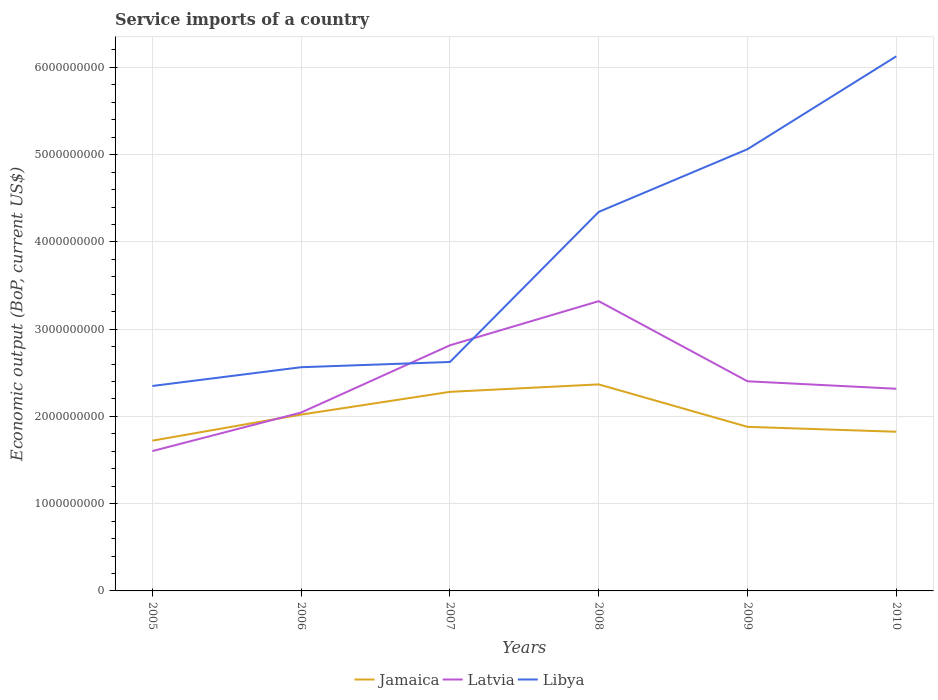Is the number of lines equal to the number of legend labels?
Your answer should be very brief. Yes. Across all years, what is the maximum service imports in Latvia?
Keep it short and to the point. 1.60e+09. What is the total service imports in Latvia in the graph?
Provide a short and direct response. -2.73e+08. What is the difference between the highest and the second highest service imports in Jamaica?
Keep it short and to the point. 6.45e+08. What is the difference between the highest and the lowest service imports in Latvia?
Provide a short and direct response. 2. Is the service imports in Latvia strictly greater than the service imports in Jamaica over the years?
Keep it short and to the point. No. How many lines are there?
Keep it short and to the point. 3. What is the difference between two consecutive major ticks on the Y-axis?
Provide a short and direct response. 1.00e+09. Does the graph contain any zero values?
Ensure brevity in your answer.  No. Does the graph contain grids?
Ensure brevity in your answer.  Yes. What is the title of the graph?
Offer a very short reply. Service imports of a country. Does "Kiribati" appear as one of the legend labels in the graph?
Offer a terse response. No. What is the label or title of the X-axis?
Offer a very short reply. Years. What is the label or title of the Y-axis?
Provide a short and direct response. Economic output (BoP, current US$). What is the Economic output (BoP, current US$) in Jamaica in 2005?
Your response must be concise. 1.72e+09. What is the Economic output (BoP, current US$) in Latvia in 2005?
Offer a terse response. 1.60e+09. What is the Economic output (BoP, current US$) of Libya in 2005?
Make the answer very short. 2.35e+09. What is the Economic output (BoP, current US$) in Jamaica in 2006?
Ensure brevity in your answer.  2.02e+09. What is the Economic output (BoP, current US$) in Latvia in 2006?
Your answer should be very brief. 2.04e+09. What is the Economic output (BoP, current US$) of Libya in 2006?
Offer a very short reply. 2.56e+09. What is the Economic output (BoP, current US$) in Jamaica in 2007?
Keep it short and to the point. 2.28e+09. What is the Economic output (BoP, current US$) in Latvia in 2007?
Your answer should be very brief. 2.82e+09. What is the Economic output (BoP, current US$) of Libya in 2007?
Provide a short and direct response. 2.62e+09. What is the Economic output (BoP, current US$) of Jamaica in 2008?
Make the answer very short. 2.37e+09. What is the Economic output (BoP, current US$) of Latvia in 2008?
Give a very brief answer. 3.32e+09. What is the Economic output (BoP, current US$) in Libya in 2008?
Offer a terse response. 4.34e+09. What is the Economic output (BoP, current US$) in Jamaica in 2009?
Your answer should be compact. 1.88e+09. What is the Economic output (BoP, current US$) of Latvia in 2009?
Keep it short and to the point. 2.40e+09. What is the Economic output (BoP, current US$) in Libya in 2009?
Provide a succinct answer. 5.06e+09. What is the Economic output (BoP, current US$) of Jamaica in 2010?
Your answer should be very brief. 1.82e+09. What is the Economic output (BoP, current US$) in Latvia in 2010?
Offer a terse response. 2.32e+09. What is the Economic output (BoP, current US$) in Libya in 2010?
Your response must be concise. 6.13e+09. Across all years, what is the maximum Economic output (BoP, current US$) of Jamaica?
Ensure brevity in your answer.  2.37e+09. Across all years, what is the maximum Economic output (BoP, current US$) of Latvia?
Your answer should be compact. 3.32e+09. Across all years, what is the maximum Economic output (BoP, current US$) in Libya?
Offer a terse response. 6.13e+09. Across all years, what is the minimum Economic output (BoP, current US$) of Jamaica?
Your answer should be very brief. 1.72e+09. Across all years, what is the minimum Economic output (BoP, current US$) of Latvia?
Offer a very short reply. 1.60e+09. Across all years, what is the minimum Economic output (BoP, current US$) of Libya?
Your answer should be very brief. 2.35e+09. What is the total Economic output (BoP, current US$) in Jamaica in the graph?
Keep it short and to the point. 1.21e+1. What is the total Economic output (BoP, current US$) in Latvia in the graph?
Provide a short and direct response. 1.45e+1. What is the total Economic output (BoP, current US$) in Libya in the graph?
Ensure brevity in your answer.  2.31e+1. What is the difference between the Economic output (BoP, current US$) of Jamaica in 2005 and that in 2006?
Give a very brief answer. -2.99e+08. What is the difference between the Economic output (BoP, current US$) of Latvia in 2005 and that in 2006?
Make the answer very short. -4.42e+08. What is the difference between the Economic output (BoP, current US$) in Libya in 2005 and that in 2006?
Make the answer very short. -2.15e+08. What is the difference between the Economic output (BoP, current US$) of Jamaica in 2005 and that in 2007?
Your answer should be very brief. -5.60e+08. What is the difference between the Economic output (BoP, current US$) of Latvia in 2005 and that in 2007?
Offer a terse response. -1.21e+09. What is the difference between the Economic output (BoP, current US$) of Libya in 2005 and that in 2007?
Provide a short and direct response. -2.75e+08. What is the difference between the Economic output (BoP, current US$) of Jamaica in 2005 and that in 2008?
Offer a very short reply. -6.45e+08. What is the difference between the Economic output (BoP, current US$) of Latvia in 2005 and that in 2008?
Your response must be concise. -1.72e+09. What is the difference between the Economic output (BoP, current US$) of Libya in 2005 and that in 2008?
Offer a very short reply. -2.00e+09. What is the difference between the Economic output (BoP, current US$) in Jamaica in 2005 and that in 2009?
Your answer should be compact. -1.59e+08. What is the difference between the Economic output (BoP, current US$) of Latvia in 2005 and that in 2009?
Your answer should be compact. -8.00e+08. What is the difference between the Economic output (BoP, current US$) of Libya in 2005 and that in 2009?
Ensure brevity in your answer.  -2.71e+09. What is the difference between the Economic output (BoP, current US$) in Jamaica in 2005 and that in 2010?
Provide a succinct answer. -1.02e+08. What is the difference between the Economic output (BoP, current US$) of Latvia in 2005 and that in 2010?
Your answer should be compact. -7.14e+08. What is the difference between the Economic output (BoP, current US$) of Libya in 2005 and that in 2010?
Offer a very short reply. -3.78e+09. What is the difference between the Economic output (BoP, current US$) in Jamaica in 2006 and that in 2007?
Give a very brief answer. -2.61e+08. What is the difference between the Economic output (BoP, current US$) in Latvia in 2006 and that in 2007?
Keep it short and to the point. -7.71e+08. What is the difference between the Economic output (BoP, current US$) of Libya in 2006 and that in 2007?
Keep it short and to the point. -6.01e+07. What is the difference between the Economic output (BoP, current US$) in Jamaica in 2006 and that in 2008?
Offer a terse response. -3.46e+08. What is the difference between the Economic output (BoP, current US$) in Latvia in 2006 and that in 2008?
Your answer should be very brief. -1.28e+09. What is the difference between the Economic output (BoP, current US$) of Libya in 2006 and that in 2008?
Keep it short and to the point. -1.78e+09. What is the difference between the Economic output (BoP, current US$) in Jamaica in 2006 and that in 2009?
Make the answer very short. 1.40e+08. What is the difference between the Economic output (BoP, current US$) of Latvia in 2006 and that in 2009?
Ensure brevity in your answer.  -3.58e+08. What is the difference between the Economic output (BoP, current US$) of Libya in 2006 and that in 2009?
Keep it short and to the point. -2.50e+09. What is the difference between the Economic output (BoP, current US$) in Jamaica in 2006 and that in 2010?
Your answer should be very brief. 1.97e+08. What is the difference between the Economic output (BoP, current US$) of Latvia in 2006 and that in 2010?
Ensure brevity in your answer.  -2.73e+08. What is the difference between the Economic output (BoP, current US$) of Libya in 2006 and that in 2010?
Provide a short and direct response. -3.56e+09. What is the difference between the Economic output (BoP, current US$) of Jamaica in 2007 and that in 2008?
Ensure brevity in your answer.  -8.54e+07. What is the difference between the Economic output (BoP, current US$) in Latvia in 2007 and that in 2008?
Your answer should be compact. -5.06e+08. What is the difference between the Economic output (BoP, current US$) in Libya in 2007 and that in 2008?
Ensure brevity in your answer.  -1.72e+09. What is the difference between the Economic output (BoP, current US$) in Jamaica in 2007 and that in 2009?
Your response must be concise. 4.01e+08. What is the difference between the Economic output (BoP, current US$) in Latvia in 2007 and that in 2009?
Keep it short and to the point. 4.12e+08. What is the difference between the Economic output (BoP, current US$) in Libya in 2007 and that in 2009?
Ensure brevity in your answer.  -2.44e+09. What is the difference between the Economic output (BoP, current US$) in Jamaica in 2007 and that in 2010?
Give a very brief answer. 4.57e+08. What is the difference between the Economic output (BoP, current US$) of Latvia in 2007 and that in 2010?
Ensure brevity in your answer.  4.98e+08. What is the difference between the Economic output (BoP, current US$) in Libya in 2007 and that in 2010?
Offer a terse response. -3.50e+09. What is the difference between the Economic output (BoP, current US$) in Jamaica in 2008 and that in 2009?
Offer a very short reply. 4.86e+08. What is the difference between the Economic output (BoP, current US$) in Latvia in 2008 and that in 2009?
Provide a short and direct response. 9.18e+08. What is the difference between the Economic output (BoP, current US$) in Libya in 2008 and that in 2009?
Offer a terse response. -7.19e+08. What is the difference between the Economic output (BoP, current US$) in Jamaica in 2008 and that in 2010?
Offer a very short reply. 5.43e+08. What is the difference between the Economic output (BoP, current US$) of Latvia in 2008 and that in 2010?
Provide a short and direct response. 1.00e+09. What is the difference between the Economic output (BoP, current US$) in Libya in 2008 and that in 2010?
Your answer should be very brief. -1.78e+09. What is the difference between the Economic output (BoP, current US$) in Jamaica in 2009 and that in 2010?
Provide a short and direct response. 5.62e+07. What is the difference between the Economic output (BoP, current US$) of Latvia in 2009 and that in 2010?
Your answer should be compact. 8.57e+07. What is the difference between the Economic output (BoP, current US$) in Libya in 2009 and that in 2010?
Your response must be concise. -1.06e+09. What is the difference between the Economic output (BoP, current US$) in Jamaica in 2005 and the Economic output (BoP, current US$) in Latvia in 2006?
Ensure brevity in your answer.  -3.23e+08. What is the difference between the Economic output (BoP, current US$) of Jamaica in 2005 and the Economic output (BoP, current US$) of Libya in 2006?
Provide a succinct answer. -8.42e+08. What is the difference between the Economic output (BoP, current US$) in Latvia in 2005 and the Economic output (BoP, current US$) in Libya in 2006?
Your response must be concise. -9.61e+08. What is the difference between the Economic output (BoP, current US$) in Jamaica in 2005 and the Economic output (BoP, current US$) in Latvia in 2007?
Provide a succinct answer. -1.09e+09. What is the difference between the Economic output (BoP, current US$) in Jamaica in 2005 and the Economic output (BoP, current US$) in Libya in 2007?
Give a very brief answer. -9.02e+08. What is the difference between the Economic output (BoP, current US$) of Latvia in 2005 and the Economic output (BoP, current US$) of Libya in 2007?
Your response must be concise. -1.02e+09. What is the difference between the Economic output (BoP, current US$) of Jamaica in 2005 and the Economic output (BoP, current US$) of Latvia in 2008?
Offer a terse response. -1.60e+09. What is the difference between the Economic output (BoP, current US$) of Jamaica in 2005 and the Economic output (BoP, current US$) of Libya in 2008?
Your answer should be compact. -2.62e+09. What is the difference between the Economic output (BoP, current US$) in Latvia in 2005 and the Economic output (BoP, current US$) in Libya in 2008?
Provide a succinct answer. -2.74e+09. What is the difference between the Economic output (BoP, current US$) in Jamaica in 2005 and the Economic output (BoP, current US$) in Latvia in 2009?
Provide a succinct answer. -6.81e+08. What is the difference between the Economic output (BoP, current US$) in Jamaica in 2005 and the Economic output (BoP, current US$) in Libya in 2009?
Your answer should be compact. -3.34e+09. What is the difference between the Economic output (BoP, current US$) of Latvia in 2005 and the Economic output (BoP, current US$) of Libya in 2009?
Ensure brevity in your answer.  -3.46e+09. What is the difference between the Economic output (BoP, current US$) in Jamaica in 2005 and the Economic output (BoP, current US$) in Latvia in 2010?
Provide a short and direct response. -5.95e+08. What is the difference between the Economic output (BoP, current US$) in Jamaica in 2005 and the Economic output (BoP, current US$) in Libya in 2010?
Offer a terse response. -4.41e+09. What is the difference between the Economic output (BoP, current US$) of Latvia in 2005 and the Economic output (BoP, current US$) of Libya in 2010?
Offer a terse response. -4.52e+09. What is the difference between the Economic output (BoP, current US$) of Jamaica in 2006 and the Economic output (BoP, current US$) of Latvia in 2007?
Provide a short and direct response. -7.94e+08. What is the difference between the Economic output (BoP, current US$) in Jamaica in 2006 and the Economic output (BoP, current US$) in Libya in 2007?
Keep it short and to the point. -6.03e+08. What is the difference between the Economic output (BoP, current US$) of Latvia in 2006 and the Economic output (BoP, current US$) of Libya in 2007?
Provide a short and direct response. -5.80e+08. What is the difference between the Economic output (BoP, current US$) in Jamaica in 2006 and the Economic output (BoP, current US$) in Latvia in 2008?
Your answer should be compact. -1.30e+09. What is the difference between the Economic output (BoP, current US$) in Jamaica in 2006 and the Economic output (BoP, current US$) in Libya in 2008?
Your answer should be compact. -2.32e+09. What is the difference between the Economic output (BoP, current US$) of Latvia in 2006 and the Economic output (BoP, current US$) of Libya in 2008?
Your answer should be compact. -2.30e+09. What is the difference between the Economic output (BoP, current US$) of Jamaica in 2006 and the Economic output (BoP, current US$) of Latvia in 2009?
Make the answer very short. -3.82e+08. What is the difference between the Economic output (BoP, current US$) in Jamaica in 2006 and the Economic output (BoP, current US$) in Libya in 2009?
Make the answer very short. -3.04e+09. What is the difference between the Economic output (BoP, current US$) of Latvia in 2006 and the Economic output (BoP, current US$) of Libya in 2009?
Ensure brevity in your answer.  -3.02e+09. What is the difference between the Economic output (BoP, current US$) in Jamaica in 2006 and the Economic output (BoP, current US$) in Latvia in 2010?
Offer a terse response. -2.96e+08. What is the difference between the Economic output (BoP, current US$) in Jamaica in 2006 and the Economic output (BoP, current US$) in Libya in 2010?
Offer a terse response. -4.11e+09. What is the difference between the Economic output (BoP, current US$) of Latvia in 2006 and the Economic output (BoP, current US$) of Libya in 2010?
Keep it short and to the point. -4.08e+09. What is the difference between the Economic output (BoP, current US$) in Jamaica in 2007 and the Economic output (BoP, current US$) in Latvia in 2008?
Give a very brief answer. -1.04e+09. What is the difference between the Economic output (BoP, current US$) in Jamaica in 2007 and the Economic output (BoP, current US$) in Libya in 2008?
Offer a terse response. -2.06e+09. What is the difference between the Economic output (BoP, current US$) in Latvia in 2007 and the Economic output (BoP, current US$) in Libya in 2008?
Give a very brief answer. -1.53e+09. What is the difference between the Economic output (BoP, current US$) of Jamaica in 2007 and the Economic output (BoP, current US$) of Latvia in 2009?
Provide a succinct answer. -1.21e+08. What is the difference between the Economic output (BoP, current US$) of Jamaica in 2007 and the Economic output (BoP, current US$) of Libya in 2009?
Make the answer very short. -2.78e+09. What is the difference between the Economic output (BoP, current US$) of Latvia in 2007 and the Economic output (BoP, current US$) of Libya in 2009?
Provide a succinct answer. -2.25e+09. What is the difference between the Economic output (BoP, current US$) in Jamaica in 2007 and the Economic output (BoP, current US$) in Latvia in 2010?
Provide a succinct answer. -3.54e+07. What is the difference between the Economic output (BoP, current US$) in Jamaica in 2007 and the Economic output (BoP, current US$) in Libya in 2010?
Your answer should be very brief. -3.85e+09. What is the difference between the Economic output (BoP, current US$) of Latvia in 2007 and the Economic output (BoP, current US$) of Libya in 2010?
Your answer should be very brief. -3.31e+09. What is the difference between the Economic output (BoP, current US$) of Jamaica in 2008 and the Economic output (BoP, current US$) of Latvia in 2009?
Ensure brevity in your answer.  -3.57e+07. What is the difference between the Economic output (BoP, current US$) of Jamaica in 2008 and the Economic output (BoP, current US$) of Libya in 2009?
Your answer should be compact. -2.70e+09. What is the difference between the Economic output (BoP, current US$) of Latvia in 2008 and the Economic output (BoP, current US$) of Libya in 2009?
Keep it short and to the point. -1.74e+09. What is the difference between the Economic output (BoP, current US$) of Jamaica in 2008 and the Economic output (BoP, current US$) of Latvia in 2010?
Ensure brevity in your answer.  5.00e+07. What is the difference between the Economic output (BoP, current US$) in Jamaica in 2008 and the Economic output (BoP, current US$) in Libya in 2010?
Offer a terse response. -3.76e+09. What is the difference between the Economic output (BoP, current US$) in Latvia in 2008 and the Economic output (BoP, current US$) in Libya in 2010?
Your answer should be very brief. -2.81e+09. What is the difference between the Economic output (BoP, current US$) in Jamaica in 2009 and the Economic output (BoP, current US$) in Latvia in 2010?
Ensure brevity in your answer.  -4.36e+08. What is the difference between the Economic output (BoP, current US$) of Jamaica in 2009 and the Economic output (BoP, current US$) of Libya in 2010?
Offer a very short reply. -4.25e+09. What is the difference between the Economic output (BoP, current US$) of Latvia in 2009 and the Economic output (BoP, current US$) of Libya in 2010?
Make the answer very short. -3.72e+09. What is the average Economic output (BoP, current US$) in Jamaica per year?
Offer a terse response. 2.02e+09. What is the average Economic output (BoP, current US$) of Latvia per year?
Give a very brief answer. 2.42e+09. What is the average Economic output (BoP, current US$) in Libya per year?
Your answer should be very brief. 3.85e+09. In the year 2005, what is the difference between the Economic output (BoP, current US$) of Jamaica and Economic output (BoP, current US$) of Latvia?
Your answer should be compact. 1.19e+08. In the year 2005, what is the difference between the Economic output (BoP, current US$) in Jamaica and Economic output (BoP, current US$) in Libya?
Your answer should be very brief. -6.27e+08. In the year 2005, what is the difference between the Economic output (BoP, current US$) of Latvia and Economic output (BoP, current US$) of Libya?
Provide a short and direct response. -7.46e+08. In the year 2006, what is the difference between the Economic output (BoP, current US$) in Jamaica and Economic output (BoP, current US$) in Latvia?
Make the answer very short. -2.35e+07. In the year 2006, what is the difference between the Economic output (BoP, current US$) in Jamaica and Economic output (BoP, current US$) in Libya?
Your answer should be compact. -5.43e+08. In the year 2006, what is the difference between the Economic output (BoP, current US$) in Latvia and Economic output (BoP, current US$) in Libya?
Your answer should be compact. -5.19e+08. In the year 2007, what is the difference between the Economic output (BoP, current US$) in Jamaica and Economic output (BoP, current US$) in Latvia?
Offer a terse response. -5.34e+08. In the year 2007, what is the difference between the Economic output (BoP, current US$) of Jamaica and Economic output (BoP, current US$) of Libya?
Offer a very short reply. -3.42e+08. In the year 2007, what is the difference between the Economic output (BoP, current US$) of Latvia and Economic output (BoP, current US$) of Libya?
Give a very brief answer. 1.91e+08. In the year 2008, what is the difference between the Economic output (BoP, current US$) of Jamaica and Economic output (BoP, current US$) of Latvia?
Ensure brevity in your answer.  -9.54e+08. In the year 2008, what is the difference between the Economic output (BoP, current US$) of Jamaica and Economic output (BoP, current US$) of Libya?
Your response must be concise. -1.98e+09. In the year 2008, what is the difference between the Economic output (BoP, current US$) in Latvia and Economic output (BoP, current US$) in Libya?
Your response must be concise. -1.02e+09. In the year 2009, what is the difference between the Economic output (BoP, current US$) in Jamaica and Economic output (BoP, current US$) in Latvia?
Your answer should be very brief. -5.22e+08. In the year 2009, what is the difference between the Economic output (BoP, current US$) of Jamaica and Economic output (BoP, current US$) of Libya?
Offer a terse response. -3.18e+09. In the year 2009, what is the difference between the Economic output (BoP, current US$) of Latvia and Economic output (BoP, current US$) of Libya?
Your answer should be compact. -2.66e+09. In the year 2010, what is the difference between the Economic output (BoP, current US$) of Jamaica and Economic output (BoP, current US$) of Latvia?
Offer a very short reply. -4.93e+08. In the year 2010, what is the difference between the Economic output (BoP, current US$) of Jamaica and Economic output (BoP, current US$) of Libya?
Offer a terse response. -4.30e+09. In the year 2010, what is the difference between the Economic output (BoP, current US$) in Latvia and Economic output (BoP, current US$) in Libya?
Offer a terse response. -3.81e+09. What is the ratio of the Economic output (BoP, current US$) of Jamaica in 2005 to that in 2006?
Give a very brief answer. 0.85. What is the ratio of the Economic output (BoP, current US$) of Latvia in 2005 to that in 2006?
Offer a terse response. 0.78. What is the ratio of the Economic output (BoP, current US$) of Libya in 2005 to that in 2006?
Offer a terse response. 0.92. What is the ratio of the Economic output (BoP, current US$) in Jamaica in 2005 to that in 2007?
Give a very brief answer. 0.75. What is the ratio of the Economic output (BoP, current US$) of Latvia in 2005 to that in 2007?
Your answer should be very brief. 0.57. What is the ratio of the Economic output (BoP, current US$) in Libya in 2005 to that in 2007?
Ensure brevity in your answer.  0.9. What is the ratio of the Economic output (BoP, current US$) of Jamaica in 2005 to that in 2008?
Offer a very short reply. 0.73. What is the ratio of the Economic output (BoP, current US$) of Latvia in 2005 to that in 2008?
Make the answer very short. 0.48. What is the ratio of the Economic output (BoP, current US$) of Libya in 2005 to that in 2008?
Your answer should be very brief. 0.54. What is the ratio of the Economic output (BoP, current US$) in Jamaica in 2005 to that in 2009?
Make the answer very short. 0.92. What is the ratio of the Economic output (BoP, current US$) in Latvia in 2005 to that in 2009?
Offer a very short reply. 0.67. What is the ratio of the Economic output (BoP, current US$) in Libya in 2005 to that in 2009?
Provide a succinct answer. 0.46. What is the ratio of the Economic output (BoP, current US$) of Jamaica in 2005 to that in 2010?
Your answer should be compact. 0.94. What is the ratio of the Economic output (BoP, current US$) in Latvia in 2005 to that in 2010?
Offer a very short reply. 0.69. What is the ratio of the Economic output (BoP, current US$) of Libya in 2005 to that in 2010?
Give a very brief answer. 0.38. What is the ratio of the Economic output (BoP, current US$) in Jamaica in 2006 to that in 2007?
Your response must be concise. 0.89. What is the ratio of the Economic output (BoP, current US$) in Latvia in 2006 to that in 2007?
Your response must be concise. 0.73. What is the ratio of the Economic output (BoP, current US$) of Libya in 2006 to that in 2007?
Provide a succinct answer. 0.98. What is the ratio of the Economic output (BoP, current US$) in Jamaica in 2006 to that in 2008?
Your response must be concise. 0.85. What is the ratio of the Economic output (BoP, current US$) of Latvia in 2006 to that in 2008?
Your response must be concise. 0.62. What is the ratio of the Economic output (BoP, current US$) of Libya in 2006 to that in 2008?
Keep it short and to the point. 0.59. What is the ratio of the Economic output (BoP, current US$) in Jamaica in 2006 to that in 2009?
Provide a succinct answer. 1.07. What is the ratio of the Economic output (BoP, current US$) of Latvia in 2006 to that in 2009?
Provide a short and direct response. 0.85. What is the ratio of the Economic output (BoP, current US$) in Libya in 2006 to that in 2009?
Your answer should be very brief. 0.51. What is the ratio of the Economic output (BoP, current US$) of Jamaica in 2006 to that in 2010?
Your answer should be compact. 1.11. What is the ratio of the Economic output (BoP, current US$) in Latvia in 2006 to that in 2010?
Provide a succinct answer. 0.88. What is the ratio of the Economic output (BoP, current US$) in Libya in 2006 to that in 2010?
Ensure brevity in your answer.  0.42. What is the ratio of the Economic output (BoP, current US$) of Jamaica in 2007 to that in 2008?
Ensure brevity in your answer.  0.96. What is the ratio of the Economic output (BoP, current US$) of Latvia in 2007 to that in 2008?
Provide a succinct answer. 0.85. What is the ratio of the Economic output (BoP, current US$) in Libya in 2007 to that in 2008?
Provide a succinct answer. 0.6. What is the ratio of the Economic output (BoP, current US$) of Jamaica in 2007 to that in 2009?
Ensure brevity in your answer.  1.21. What is the ratio of the Economic output (BoP, current US$) in Latvia in 2007 to that in 2009?
Provide a short and direct response. 1.17. What is the ratio of the Economic output (BoP, current US$) of Libya in 2007 to that in 2009?
Your answer should be compact. 0.52. What is the ratio of the Economic output (BoP, current US$) in Jamaica in 2007 to that in 2010?
Make the answer very short. 1.25. What is the ratio of the Economic output (BoP, current US$) in Latvia in 2007 to that in 2010?
Give a very brief answer. 1.22. What is the ratio of the Economic output (BoP, current US$) of Libya in 2007 to that in 2010?
Your answer should be compact. 0.43. What is the ratio of the Economic output (BoP, current US$) in Jamaica in 2008 to that in 2009?
Offer a very short reply. 1.26. What is the ratio of the Economic output (BoP, current US$) in Latvia in 2008 to that in 2009?
Your response must be concise. 1.38. What is the ratio of the Economic output (BoP, current US$) in Libya in 2008 to that in 2009?
Give a very brief answer. 0.86. What is the ratio of the Economic output (BoP, current US$) in Jamaica in 2008 to that in 2010?
Your answer should be very brief. 1.3. What is the ratio of the Economic output (BoP, current US$) in Latvia in 2008 to that in 2010?
Provide a succinct answer. 1.43. What is the ratio of the Economic output (BoP, current US$) of Libya in 2008 to that in 2010?
Provide a short and direct response. 0.71. What is the ratio of the Economic output (BoP, current US$) in Jamaica in 2009 to that in 2010?
Provide a short and direct response. 1.03. What is the ratio of the Economic output (BoP, current US$) of Libya in 2009 to that in 2010?
Make the answer very short. 0.83. What is the difference between the highest and the second highest Economic output (BoP, current US$) in Jamaica?
Ensure brevity in your answer.  8.54e+07. What is the difference between the highest and the second highest Economic output (BoP, current US$) of Latvia?
Offer a very short reply. 5.06e+08. What is the difference between the highest and the second highest Economic output (BoP, current US$) of Libya?
Make the answer very short. 1.06e+09. What is the difference between the highest and the lowest Economic output (BoP, current US$) of Jamaica?
Offer a terse response. 6.45e+08. What is the difference between the highest and the lowest Economic output (BoP, current US$) in Latvia?
Make the answer very short. 1.72e+09. What is the difference between the highest and the lowest Economic output (BoP, current US$) of Libya?
Your response must be concise. 3.78e+09. 